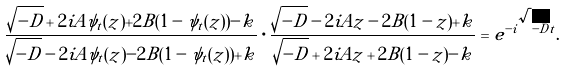<formula> <loc_0><loc_0><loc_500><loc_500>\frac { \sqrt { - D } + 2 i A \psi _ { t } ( z ) + 2 B ( 1 - \psi _ { t } ( z ) ) - k } { \sqrt { - D } - 2 i A \psi _ { t } ( z ) - 2 B ( 1 - \psi _ { t } ( z ) ) + k } \cdot \frac { \sqrt { - D } - 2 i A z - 2 B ( 1 - z ) + k } { \sqrt { - D } + 2 i A z + 2 B ( 1 - z ) - k } = e ^ { - i \sqrt { - D } t } .</formula> 